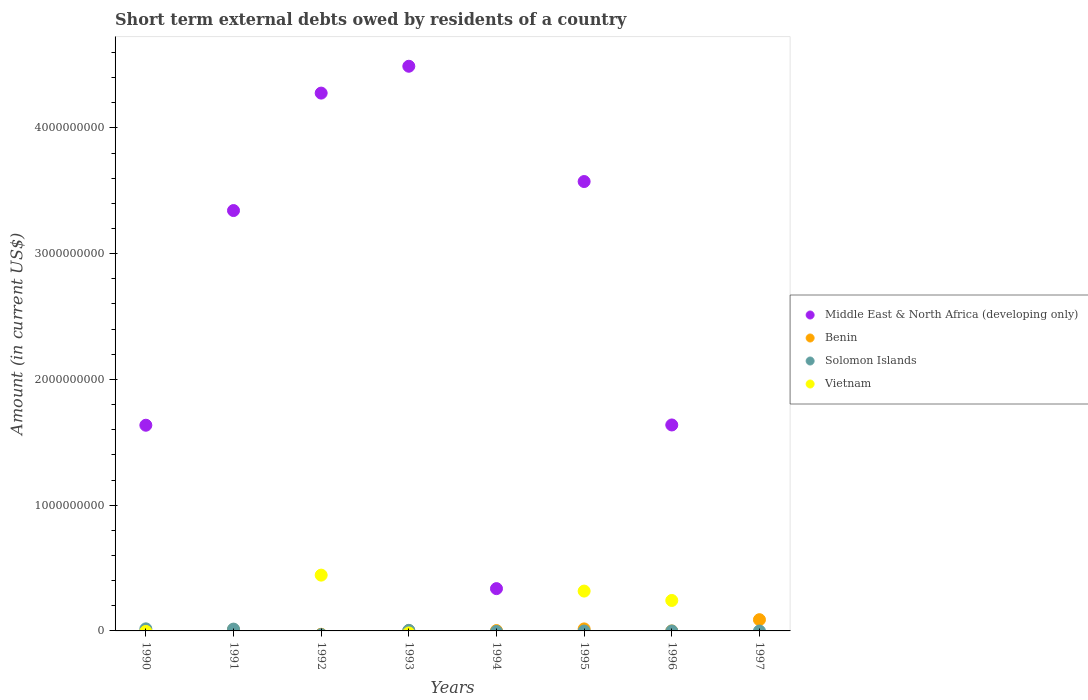How many different coloured dotlines are there?
Offer a terse response. 4. What is the amount of short-term external debts owed by residents in Benin in 1994?
Your response must be concise. 2.71e+06. Across all years, what is the maximum amount of short-term external debts owed by residents in Middle East & North Africa (developing only)?
Your answer should be very brief. 4.49e+09. In which year was the amount of short-term external debts owed by residents in Solomon Islands maximum?
Ensure brevity in your answer.  1990. What is the total amount of short-term external debts owed by residents in Vietnam in the graph?
Provide a succinct answer. 1.00e+09. What is the difference between the amount of short-term external debts owed by residents in Middle East & North Africa (developing only) in 1990 and that in 1996?
Give a very brief answer. -2.08e+06. What is the average amount of short-term external debts owed by residents in Vietnam per year?
Offer a very short reply. 1.25e+08. In the year 1995, what is the difference between the amount of short-term external debts owed by residents in Vietnam and amount of short-term external debts owed by residents in Benin?
Give a very brief answer. 3.01e+08. What is the ratio of the amount of short-term external debts owed by residents in Solomon Islands in 1990 to that in 1993?
Keep it short and to the point. 3.64. Is the amount of short-term external debts owed by residents in Benin in 1993 less than that in 1997?
Keep it short and to the point. Yes. What is the difference between the highest and the second highest amount of short-term external debts owed by residents in Middle East & North Africa (developing only)?
Your response must be concise. 2.13e+08. What is the difference between the highest and the lowest amount of short-term external debts owed by residents in Vietnam?
Offer a terse response. 4.44e+08. Is it the case that in every year, the sum of the amount of short-term external debts owed by residents in Solomon Islands and amount of short-term external debts owed by residents in Benin  is greater than the amount of short-term external debts owed by residents in Middle East & North Africa (developing only)?
Your answer should be compact. No. Is the amount of short-term external debts owed by residents in Solomon Islands strictly greater than the amount of short-term external debts owed by residents in Benin over the years?
Provide a succinct answer. No. Is the amount of short-term external debts owed by residents in Solomon Islands strictly less than the amount of short-term external debts owed by residents in Middle East & North Africa (developing only) over the years?
Provide a succinct answer. No. How many years are there in the graph?
Provide a succinct answer. 8. How many legend labels are there?
Offer a terse response. 4. How are the legend labels stacked?
Provide a succinct answer. Vertical. What is the title of the graph?
Give a very brief answer. Short term external debts owed by residents of a country. What is the Amount (in current US$) of Middle East & North Africa (developing only) in 1990?
Offer a very short reply. 1.64e+09. What is the Amount (in current US$) of Benin in 1990?
Your answer should be very brief. 0. What is the Amount (in current US$) in Solomon Islands in 1990?
Provide a short and direct response. 1.65e+07. What is the Amount (in current US$) of Vietnam in 1990?
Ensure brevity in your answer.  0. What is the Amount (in current US$) in Middle East & North Africa (developing only) in 1991?
Make the answer very short. 3.34e+09. What is the Amount (in current US$) of Benin in 1991?
Provide a succinct answer. 1.01e+07. What is the Amount (in current US$) in Solomon Islands in 1991?
Provide a short and direct response. 1.45e+07. What is the Amount (in current US$) of Vietnam in 1991?
Your answer should be compact. 0. What is the Amount (in current US$) in Middle East & North Africa (developing only) in 1992?
Give a very brief answer. 4.28e+09. What is the Amount (in current US$) of Vietnam in 1992?
Your response must be concise. 4.44e+08. What is the Amount (in current US$) in Middle East & North Africa (developing only) in 1993?
Your response must be concise. 4.49e+09. What is the Amount (in current US$) in Benin in 1993?
Offer a very short reply. 1.97e+06. What is the Amount (in current US$) of Solomon Islands in 1993?
Your answer should be compact. 4.53e+06. What is the Amount (in current US$) in Middle East & North Africa (developing only) in 1994?
Your answer should be very brief. 3.36e+08. What is the Amount (in current US$) of Benin in 1994?
Keep it short and to the point. 2.71e+06. What is the Amount (in current US$) of Vietnam in 1994?
Your answer should be very brief. 0. What is the Amount (in current US$) in Middle East & North Africa (developing only) in 1995?
Make the answer very short. 3.57e+09. What is the Amount (in current US$) of Benin in 1995?
Provide a short and direct response. 1.60e+07. What is the Amount (in current US$) of Solomon Islands in 1995?
Offer a terse response. 0. What is the Amount (in current US$) of Vietnam in 1995?
Offer a very short reply. 3.17e+08. What is the Amount (in current US$) of Middle East & North Africa (developing only) in 1996?
Keep it short and to the point. 1.64e+09. What is the Amount (in current US$) of Solomon Islands in 1996?
Make the answer very short. 0. What is the Amount (in current US$) in Vietnam in 1996?
Ensure brevity in your answer.  2.42e+08. What is the Amount (in current US$) of Benin in 1997?
Keep it short and to the point. 8.93e+07. Across all years, what is the maximum Amount (in current US$) of Middle East & North Africa (developing only)?
Provide a succinct answer. 4.49e+09. Across all years, what is the maximum Amount (in current US$) of Benin?
Keep it short and to the point. 8.93e+07. Across all years, what is the maximum Amount (in current US$) in Solomon Islands?
Your answer should be very brief. 1.65e+07. Across all years, what is the maximum Amount (in current US$) in Vietnam?
Your answer should be compact. 4.44e+08. Across all years, what is the minimum Amount (in current US$) of Middle East & North Africa (developing only)?
Provide a succinct answer. 0. Across all years, what is the minimum Amount (in current US$) in Benin?
Your response must be concise. 0. Across all years, what is the minimum Amount (in current US$) in Solomon Islands?
Make the answer very short. 0. What is the total Amount (in current US$) in Middle East & North Africa (developing only) in the graph?
Offer a terse response. 1.93e+1. What is the total Amount (in current US$) of Benin in the graph?
Ensure brevity in your answer.  1.20e+08. What is the total Amount (in current US$) of Solomon Islands in the graph?
Offer a very short reply. 3.55e+07. What is the total Amount (in current US$) in Vietnam in the graph?
Ensure brevity in your answer.  1.00e+09. What is the difference between the Amount (in current US$) of Middle East & North Africa (developing only) in 1990 and that in 1991?
Offer a terse response. -1.71e+09. What is the difference between the Amount (in current US$) of Solomon Islands in 1990 and that in 1991?
Keep it short and to the point. 2.02e+06. What is the difference between the Amount (in current US$) of Middle East & North Africa (developing only) in 1990 and that in 1992?
Your answer should be very brief. -2.64e+09. What is the difference between the Amount (in current US$) of Middle East & North Africa (developing only) in 1990 and that in 1993?
Offer a terse response. -2.85e+09. What is the difference between the Amount (in current US$) in Solomon Islands in 1990 and that in 1993?
Offer a very short reply. 1.20e+07. What is the difference between the Amount (in current US$) of Middle East & North Africa (developing only) in 1990 and that in 1994?
Make the answer very short. 1.30e+09. What is the difference between the Amount (in current US$) of Middle East & North Africa (developing only) in 1990 and that in 1995?
Give a very brief answer. -1.94e+09. What is the difference between the Amount (in current US$) of Middle East & North Africa (developing only) in 1990 and that in 1996?
Provide a short and direct response. -2.08e+06. What is the difference between the Amount (in current US$) of Middle East & North Africa (developing only) in 1991 and that in 1992?
Make the answer very short. -9.34e+08. What is the difference between the Amount (in current US$) in Middle East & North Africa (developing only) in 1991 and that in 1993?
Your answer should be compact. -1.15e+09. What is the difference between the Amount (in current US$) of Benin in 1991 and that in 1993?
Offer a very short reply. 8.14e+06. What is the difference between the Amount (in current US$) of Solomon Islands in 1991 and that in 1993?
Ensure brevity in your answer.  9.96e+06. What is the difference between the Amount (in current US$) in Middle East & North Africa (developing only) in 1991 and that in 1994?
Your answer should be very brief. 3.01e+09. What is the difference between the Amount (in current US$) in Benin in 1991 and that in 1994?
Your response must be concise. 7.40e+06. What is the difference between the Amount (in current US$) of Middle East & North Africa (developing only) in 1991 and that in 1995?
Your response must be concise. -2.31e+08. What is the difference between the Amount (in current US$) of Benin in 1991 and that in 1995?
Keep it short and to the point. -5.87e+06. What is the difference between the Amount (in current US$) in Middle East & North Africa (developing only) in 1991 and that in 1996?
Make the answer very short. 1.70e+09. What is the difference between the Amount (in current US$) in Benin in 1991 and that in 1997?
Give a very brief answer. -7.92e+07. What is the difference between the Amount (in current US$) of Middle East & North Africa (developing only) in 1992 and that in 1993?
Provide a short and direct response. -2.13e+08. What is the difference between the Amount (in current US$) in Middle East & North Africa (developing only) in 1992 and that in 1994?
Offer a terse response. 3.94e+09. What is the difference between the Amount (in current US$) of Middle East & North Africa (developing only) in 1992 and that in 1995?
Your answer should be very brief. 7.03e+08. What is the difference between the Amount (in current US$) of Vietnam in 1992 and that in 1995?
Provide a succinct answer. 1.27e+08. What is the difference between the Amount (in current US$) of Middle East & North Africa (developing only) in 1992 and that in 1996?
Keep it short and to the point. 2.64e+09. What is the difference between the Amount (in current US$) of Vietnam in 1992 and that in 1996?
Provide a short and direct response. 2.01e+08. What is the difference between the Amount (in current US$) in Middle East & North Africa (developing only) in 1993 and that in 1994?
Offer a terse response. 4.15e+09. What is the difference between the Amount (in current US$) of Benin in 1993 and that in 1994?
Keep it short and to the point. -7.40e+05. What is the difference between the Amount (in current US$) of Middle East & North Africa (developing only) in 1993 and that in 1995?
Ensure brevity in your answer.  9.17e+08. What is the difference between the Amount (in current US$) in Benin in 1993 and that in 1995?
Your response must be concise. -1.40e+07. What is the difference between the Amount (in current US$) of Middle East & North Africa (developing only) in 1993 and that in 1996?
Ensure brevity in your answer.  2.85e+09. What is the difference between the Amount (in current US$) of Benin in 1993 and that in 1997?
Offer a terse response. -8.74e+07. What is the difference between the Amount (in current US$) in Middle East & North Africa (developing only) in 1994 and that in 1995?
Offer a very short reply. -3.24e+09. What is the difference between the Amount (in current US$) in Benin in 1994 and that in 1995?
Give a very brief answer. -1.33e+07. What is the difference between the Amount (in current US$) in Middle East & North Africa (developing only) in 1994 and that in 1996?
Give a very brief answer. -1.30e+09. What is the difference between the Amount (in current US$) of Benin in 1994 and that in 1997?
Ensure brevity in your answer.  -8.66e+07. What is the difference between the Amount (in current US$) of Middle East & North Africa (developing only) in 1995 and that in 1996?
Provide a short and direct response. 1.94e+09. What is the difference between the Amount (in current US$) in Vietnam in 1995 and that in 1996?
Provide a succinct answer. 7.46e+07. What is the difference between the Amount (in current US$) in Benin in 1995 and that in 1997?
Your answer should be compact. -7.34e+07. What is the difference between the Amount (in current US$) of Middle East & North Africa (developing only) in 1990 and the Amount (in current US$) of Benin in 1991?
Offer a terse response. 1.63e+09. What is the difference between the Amount (in current US$) of Middle East & North Africa (developing only) in 1990 and the Amount (in current US$) of Solomon Islands in 1991?
Give a very brief answer. 1.62e+09. What is the difference between the Amount (in current US$) of Middle East & North Africa (developing only) in 1990 and the Amount (in current US$) of Vietnam in 1992?
Your answer should be compact. 1.19e+09. What is the difference between the Amount (in current US$) in Solomon Islands in 1990 and the Amount (in current US$) in Vietnam in 1992?
Ensure brevity in your answer.  -4.27e+08. What is the difference between the Amount (in current US$) of Middle East & North Africa (developing only) in 1990 and the Amount (in current US$) of Benin in 1993?
Keep it short and to the point. 1.63e+09. What is the difference between the Amount (in current US$) in Middle East & North Africa (developing only) in 1990 and the Amount (in current US$) in Solomon Islands in 1993?
Ensure brevity in your answer.  1.63e+09. What is the difference between the Amount (in current US$) of Middle East & North Africa (developing only) in 1990 and the Amount (in current US$) of Benin in 1994?
Offer a terse response. 1.63e+09. What is the difference between the Amount (in current US$) in Middle East & North Africa (developing only) in 1990 and the Amount (in current US$) in Benin in 1995?
Keep it short and to the point. 1.62e+09. What is the difference between the Amount (in current US$) in Middle East & North Africa (developing only) in 1990 and the Amount (in current US$) in Vietnam in 1995?
Offer a very short reply. 1.32e+09. What is the difference between the Amount (in current US$) in Solomon Islands in 1990 and the Amount (in current US$) in Vietnam in 1995?
Your answer should be very brief. -3.00e+08. What is the difference between the Amount (in current US$) in Middle East & North Africa (developing only) in 1990 and the Amount (in current US$) in Vietnam in 1996?
Give a very brief answer. 1.39e+09. What is the difference between the Amount (in current US$) of Solomon Islands in 1990 and the Amount (in current US$) of Vietnam in 1996?
Provide a short and direct response. -2.26e+08. What is the difference between the Amount (in current US$) of Middle East & North Africa (developing only) in 1990 and the Amount (in current US$) of Benin in 1997?
Provide a succinct answer. 1.55e+09. What is the difference between the Amount (in current US$) in Middle East & North Africa (developing only) in 1991 and the Amount (in current US$) in Vietnam in 1992?
Offer a very short reply. 2.90e+09. What is the difference between the Amount (in current US$) in Benin in 1991 and the Amount (in current US$) in Vietnam in 1992?
Provide a short and direct response. -4.34e+08. What is the difference between the Amount (in current US$) in Solomon Islands in 1991 and the Amount (in current US$) in Vietnam in 1992?
Make the answer very short. -4.29e+08. What is the difference between the Amount (in current US$) of Middle East & North Africa (developing only) in 1991 and the Amount (in current US$) of Benin in 1993?
Your answer should be very brief. 3.34e+09. What is the difference between the Amount (in current US$) of Middle East & North Africa (developing only) in 1991 and the Amount (in current US$) of Solomon Islands in 1993?
Your answer should be compact. 3.34e+09. What is the difference between the Amount (in current US$) in Benin in 1991 and the Amount (in current US$) in Solomon Islands in 1993?
Offer a very short reply. 5.58e+06. What is the difference between the Amount (in current US$) of Middle East & North Africa (developing only) in 1991 and the Amount (in current US$) of Benin in 1994?
Give a very brief answer. 3.34e+09. What is the difference between the Amount (in current US$) in Middle East & North Africa (developing only) in 1991 and the Amount (in current US$) in Benin in 1995?
Provide a short and direct response. 3.33e+09. What is the difference between the Amount (in current US$) of Middle East & North Africa (developing only) in 1991 and the Amount (in current US$) of Vietnam in 1995?
Your response must be concise. 3.03e+09. What is the difference between the Amount (in current US$) in Benin in 1991 and the Amount (in current US$) in Vietnam in 1995?
Provide a succinct answer. -3.07e+08. What is the difference between the Amount (in current US$) of Solomon Islands in 1991 and the Amount (in current US$) of Vietnam in 1995?
Offer a terse response. -3.02e+08. What is the difference between the Amount (in current US$) of Middle East & North Africa (developing only) in 1991 and the Amount (in current US$) of Vietnam in 1996?
Provide a short and direct response. 3.10e+09. What is the difference between the Amount (in current US$) in Benin in 1991 and the Amount (in current US$) in Vietnam in 1996?
Your response must be concise. -2.32e+08. What is the difference between the Amount (in current US$) in Solomon Islands in 1991 and the Amount (in current US$) in Vietnam in 1996?
Provide a succinct answer. -2.28e+08. What is the difference between the Amount (in current US$) of Middle East & North Africa (developing only) in 1991 and the Amount (in current US$) of Benin in 1997?
Your response must be concise. 3.25e+09. What is the difference between the Amount (in current US$) in Middle East & North Africa (developing only) in 1992 and the Amount (in current US$) in Benin in 1993?
Make the answer very short. 4.27e+09. What is the difference between the Amount (in current US$) in Middle East & North Africa (developing only) in 1992 and the Amount (in current US$) in Solomon Islands in 1993?
Give a very brief answer. 4.27e+09. What is the difference between the Amount (in current US$) in Middle East & North Africa (developing only) in 1992 and the Amount (in current US$) in Benin in 1994?
Make the answer very short. 4.27e+09. What is the difference between the Amount (in current US$) of Middle East & North Africa (developing only) in 1992 and the Amount (in current US$) of Benin in 1995?
Keep it short and to the point. 4.26e+09. What is the difference between the Amount (in current US$) in Middle East & North Africa (developing only) in 1992 and the Amount (in current US$) in Vietnam in 1995?
Provide a short and direct response. 3.96e+09. What is the difference between the Amount (in current US$) in Middle East & North Africa (developing only) in 1992 and the Amount (in current US$) in Vietnam in 1996?
Offer a very short reply. 4.03e+09. What is the difference between the Amount (in current US$) of Middle East & North Africa (developing only) in 1992 and the Amount (in current US$) of Benin in 1997?
Offer a very short reply. 4.19e+09. What is the difference between the Amount (in current US$) in Middle East & North Africa (developing only) in 1993 and the Amount (in current US$) in Benin in 1994?
Give a very brief answer. 4.49e+09. What is the difference between the Amount (in current US$) of Middle East & North Africa (developing only) in 1993 and the Amount (in current US$) of Benin in 1995?
Keep it short and to the point. 4.47e+09. What is the difference between the Amount (in current US$) of Middle East & North Africa (developing only) in 1993 and the Amount (in current US$) of Vietnam in 1995?
Provide a succinct answer. 4.17e+09. What is the difference between the Amount (in current US$) of Benin in 1993 and the Amount (in current US$) of Vietnam in 1995?
Offer a very short reply. -3.15e+08. What is the difference between the Amount (in current US$) in Solomon Islands in 1993 and the Amount (in current US$) in Vietnam in 1995?
Provide a succinct answer. -3.12e+08. What is the difference between the Amount (in current US$) in Middle East & North Africa (developing only) in 1993 and the Amount (in current US$) in Vietnam in 1996?
Your answer should be very brief. 4.25e+09. What is the difference between the Amount (in current US$) in Benin in 1993 and the Amount (in current US$) in Vietnam in 1996?
Provide a succinct answer. -2.40e+08. What is the difference between the Amount (in current US$) in Solomon Islands in 1993 and the Amount (in current US$) in Vietnam in 1996?
Provide a short and direct response. -2.38e+08. What is the difference between the Amount (in current US$) of Middle East & North Africa (developing only) in 1993 and the Amount (in current US$) of Benin in 1997?
Offer a terse response. 4.40e+09. What is the difference between the Amount (in current US$) in Middle East & North Africa (developing only) in 1994 and the Amount (in current US$) in Benin in 1995?
Your answer should be compact. 3.20e+08. What is the difference between the Amount (in current US$) in Middle East & North Africa (developing only) in 1994 and the Amount (in current US$) in Vietnam in 1995?
Keep it short and to the point. 1.95e+07. What is the difference between the Amount (in current US$) of Benin in 1994 and the Amount (in current US$) of Vietnam in 1995?
Offer a terse response. -3.14e+08. What is the difference between the Amount (in current US$) of Middle East & North Africa (developing only) in 1994 and the Amount (in current US$) of Vietnam in 1996?
Your response must be concise. 9.41e+07. What is the difference between the Amount (in current US$) in Benin in 1994 and the Amount (in current US$) in Vietnam in 1996?
Provide a succinct answer. -2.39e+08. What is the difference between the Amount (in current US$) of Middle East & North Africa (developing only) in 1994 and the Amount (in current US$) of Benin in 1997?
Provide a short and direct response. 2.47e+08. What is the difference between the Amount (in current US$) in Middle East & North Africa (developing only) in 1995 and the Amount (in current US$) in Vietnam in 1996?
Provide a succinct answer. 3.33e+09. What is the difference between the Amount (in current US$) in Benin in 1995 and the Amount (in current US$) in Vietnam in 1996?
Your answer should be compact. -2.26e+08. What is the difference between the Amount (in current US$) in Middle East & North Africa (developing only) in 1995 and the Amount (in current US$) in Benin in 1997?
Your answer should be compact. 3.48e+09. What is the difference between the Amount (in current US$) in Middle East & North Africa (developing only) in 1996 and the Amount (in current US$) in Benin in 1997?
Ensure brevity in your answer.  1.55e+09. What is the average Amount (in current US$) in Middle East & North Africa (developing only) per year?
Your answer should be very brief. 2.41e+09. What is the average Amount (in current US$) in Benin per year?
Provide a succinct answer. 1.50e+07. What is the average Amount (in current US$) of Solomon Islands per year?
Ensure brevity in your answer.  4.44e+06. What is the average Amount (in current US$) in Vietnam per year?
Offer a very short reply. 1.25e+08. In the year 1990, what is the difference between the Amount (in current US$) in Middle East & North Africa (developing only) and Amount (in current US$) in Solomon Islands?
Your answer should be very brief. 1.62e+09. In the year 1991, what is the difference between the Amount (in current US$) of Middle East & North Africa (developing only) and Amount (in current US$) of Benin?
Make the answer very short. 3.33e+09. In the year 1991, what is the difference between the Amount (in current US$) of Middle East & North Africa (developing only) and Amount (in current US$) of Solomon Islands?
Make the answer very short. 3.33e+09. In the year 1991, what is the difference between the Amount (in current US$) in Benin and Amount (in current US$) in Solomon Islands?
Your answer should be very brief. -4.38e+06. In the year 1992, what is the difference between the Amount (in current US$) in Middle East & North Africa (developing only) and Amount (in current US$) in Vietnam?
Your answer should be compact. 3.83e+09. In the year 1993, what is the difference between the Amount (in current US$) of Middle East & North Africa (developing only) and Amount (in current US$) of Benin?
Offer a terse response. 4.49e+09. In the year 1993, what is the difference between the Amount (in current US$) in Middle East & North Africa (developing only) and Amount (in current US$) in Solomon Islands?
Give a very brief answer. 4.49e+09. In the year 1993, what is the difference between the Amount (in current US$) in Benin and Amount (in current US$) in Solomon Islands?
Make the answer very short. -2.56e+06. In the year 1994, what is the difference between the Amount (in current US$) of Middle East & North Africa (developing only) and Amount (in current US$) of Benin?
Make the answer very short. 3.34e+08. In the year 1995, what is the difference between the Amount (in current US$) in Middle East & North Africa (developing only) and Amount (in current US$) in Benin?
Your answer should be very brief. 3.56e+09. In the year 1995, what is the difference between the Amount (in current US$) of Middle East & North Africa (developing only) and Amount (in current US$) of Vietnam?
Offer a very short reply. 3.26e+09. In the year 1995, what is the difference between the Amount (in current US$) in Benin and Amount (in current US$) in Vietnam?
Offer a terse response. -3.01e+08. In the year 1996, what is the difference between the Amount (in current US$) of Middle East & North Africa (developing only) and Amount (in current US$) of Vietnam?
Offer a very short reply. 1.40e+09. What is the ratio of the Amount (in current US$) of Middle East & North Africa (developing only) in 1990 to that in 1991?
Offer a very short reply. 0.49. What is the ratio of the Amount (in current US$) of Solomon Islands in 1990 to that in 1991?
Ensure brevity in your answer.  1.14. What is the ratio of the Amount (in current US$) of Middle East & North Africa (developing only) in 1990 to that in 1992?
Give a very brief answer. 0.38. What is the ratio of the Amount (in current US$) of Middle East & North Africa (developing only) in 1990 to that in 1993?
Keep it short and to the point. 0.36. What is the ratio of the Amount (in current US$) of Solomon Islands in 1990 to that in 1993?
Provide a short and direct response. 3.64. What is the ratio of the Amount (in current US$) in Middle East & North Africa (developing only) in 1990 to that in 1994?
Ensure brevity in your answer.  4.86. What is the ratio of the Amount (in current US$) of Middle East & North Africa (developing only) in 1990 to that in 1995?
Your answer should be compact. 0.46. What is the ratio of the Amount (in current US$) of Middle East & North Africa (developing only) in 1990 to that in 1996?
Provide a short and direct response. 1. What is the ratio of the Amount (in current US$) of Middle East & North Africa (developing only) in 1991 to that in 1992?
Ensure brevity in your answer.  0.78. What is the ratio of the Amount (in current US$) in Middle East & North Africa (developing only) in 1991 to that in 1993?
Provide a succinct answer. 0.74. What is the ratio of the Amount (in current US$) of Benin in 1991 to that in 1993?
Your answer should be compact. 5.13. What is the ratio of the Amount (in current US$) of Solomon Islands in 1991 to that in 1993?
Provide a short and direct response. 3.2. What is the ratio of the Amount (in current US$) of Middle East & North Africa (developing only) in 1991 to that in 1994?
Keep it short and to the point. 9.94. What is the ratio of the Amount (in current US$) in Benin in 1991 to that in 1994?
Your response must be concise. 3.73. What is the ratio of the Amount (in current US$) in Middle East & North Africa (developing only) in 1991 to that in 1995?
Give a very brief answer. 0.94. What is the ratio of the Amount (in current US$) of Benin in 1991 to that in 1995?
Ensure brevity in your answer.  0.63. What is the ratio of the Amount (in current US$) of Middle East & North Africa (developing only) in 1991 to that in 1996?
Your response must be concise. 2.04. What is the ratio of the Amount (in current US$) in Benin in 1991 to that in 1997?
Keep it short and to the point. 0.11. What is the ratio of the Amount (in current US$) in Middle East & North Africa (developing only) in 1992 to that in 1993?
Give a very brief answer. 0.95. What is the ratio of the Amount (in current US$) in Middle East & North Africa (developing only) in 1992 to that in 1994?
Offer a very short reply. 12.72. What is the ratio of the Amount (in current US$) of Middle East & North Africa (developing only) in 1992 to that in 1995?
Ensure brevity in your answer.  1.2. What is the ratio of the Amount (in current US$) in Vietnam in 1992 to that in 1995?
Ensure brevity in your answer.  1.4. What is the ratio of the Amount (in current US$) of Middle East & North Africa (developing only) in 1992 to that in 1996?
Offer a very short reply. 2.61. What is the ratio of the Amount (in current US$) in Vietnam in 1992 to that in 1996?
Offer a very short reply. 1.83. What is the ratio of the Amount (in current US$) in Middle East & North Africa (developing only) in 1993 to that in 1994?
Keep it short and to the point. 13.35. What is the ratio of the Amount (in current US$) of Benin in 1993 to that in 1994?
Offer a very short reply. 0.73. What is the ratio of the Amount (in current US$) of Middle East & North Africa (developing only) in 1993 to that in 1995?
Keep it short and to the point. 1.26. What is the ratio of the Amount (in current US$) of Benin in 1993 to that in 1995?
Offer a terse response. 0.12. What is the ratio of the Amount (in current US$) of Middle East & North Africa (developing only) in 1993 to that in 1996?
Your answer should be very brief. 2.74. What is the ratio of the Amount (in current US$) of Benin in 1993 to that in 1997?
Provide a short and direct response. 0.02. What is the ratio of the Amount (in current US$) in Middle East & North Africa (developing only) in 1994 to that in 1995?
Your response must be concise. 0.09. What is the ratio of the Amount (in current US$) of Benin in 1994 to that in 1995?
Ensure brevity in your answer.  0.17. What is the ratio of the Amount (in current US$) in Middle East & North Africa (developing only) in 1994 to that in 1996?
Offer a very short reply. 0.21. What is the ratio of the Amount (in current US$) of Benin in 1994 to that in 1997?
Your response must be concise. 0.03. What is the ratio of the Amount (in current US$) in Middle East & North Africa (developing only) in 1995 to that in 1996?
Provide a short and direct response. 2.18. What is the ratio of the Amount (in current US$) in Vietnam in 1995 to that in 1996?
Provide a succinct answer. 1.31. What is the ratio of the Amount (in current US$) of Benin in 1995 to that in 1997?
Keep it short and to the point. 0.18. What is the difference between the highest and the second highest Amount (in current US$) of Middle East & North Africa (developing only)?
Your response must be concise. 2.13e+08. What is the difference between the highest and the second highest Amount (in current US$) of Benin?
Give a very brief answer. 7.34e+07. What is the difference between the highest and the second highest Amount (in current US$) in Solomon Islands?
Provide a succinct answer. 2.02e+06. What is the difference between the highest and the second highest Amount (in current US$) of Vietnam?
Provide a succinct answer. 1.27e+08. What is the difference between the highest and the lowest Amount (in current US$) in Middle East & North Africa (developing only)?
Ensure brevity in your answer.  4.49e+09. What is the difference between the highest and the lowest Amount (in current US$) in Benin?
Make the answer very short. 8.93e+07. What is the difference between the highest and the lowest Amount (in current US$) of Solomon Islands?
Offer a very short reply. 1.65e+07. What is the difference between the highest and the lowest Amount (in current US$) in Vietnam?
Your answer should be very brief. 4.44e+08. 